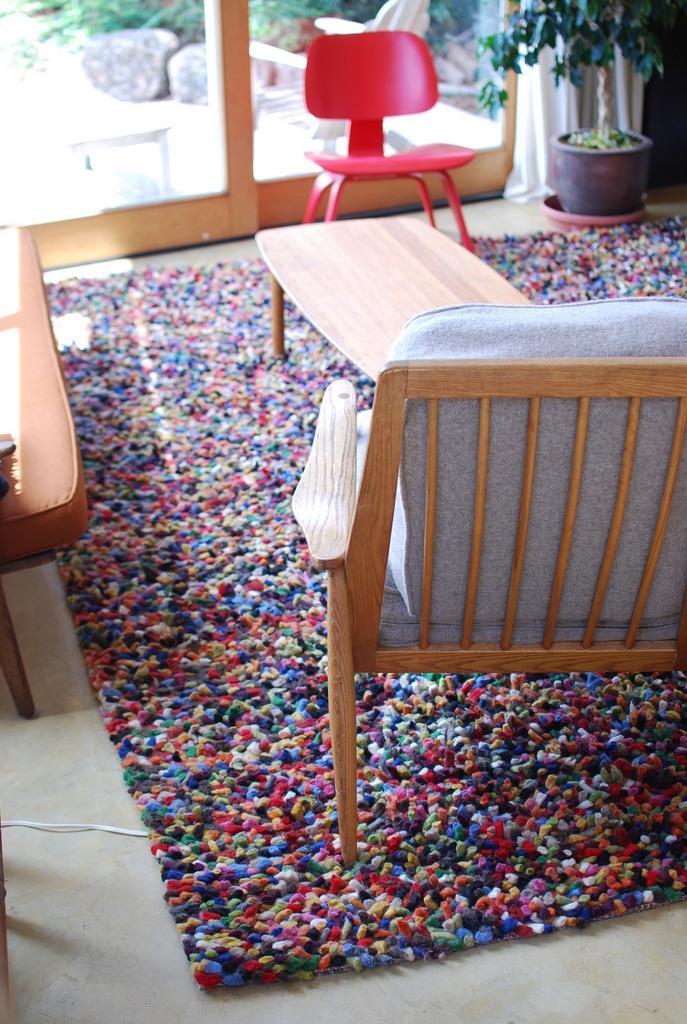Can you describe this image briefly? In this picture we can see inside view of a room, in this we can see chairs and a table on the carpet, in the top right hand corner we can see a plant and curtains. 